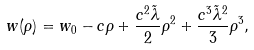<formula> <loc_0><loc_0><loc_500><loc_500>w ( \rho ) = w _ { 0 } - c \rho + \frac { c ^ { 2 } \tilde { \lambda } } { 2 } \rho ^ { 2 } + \frac { c ^ { 3 } \tilde { \lambda } ^ { 2 } } { 3 } \rho ^ { 3 } ,</formula> 